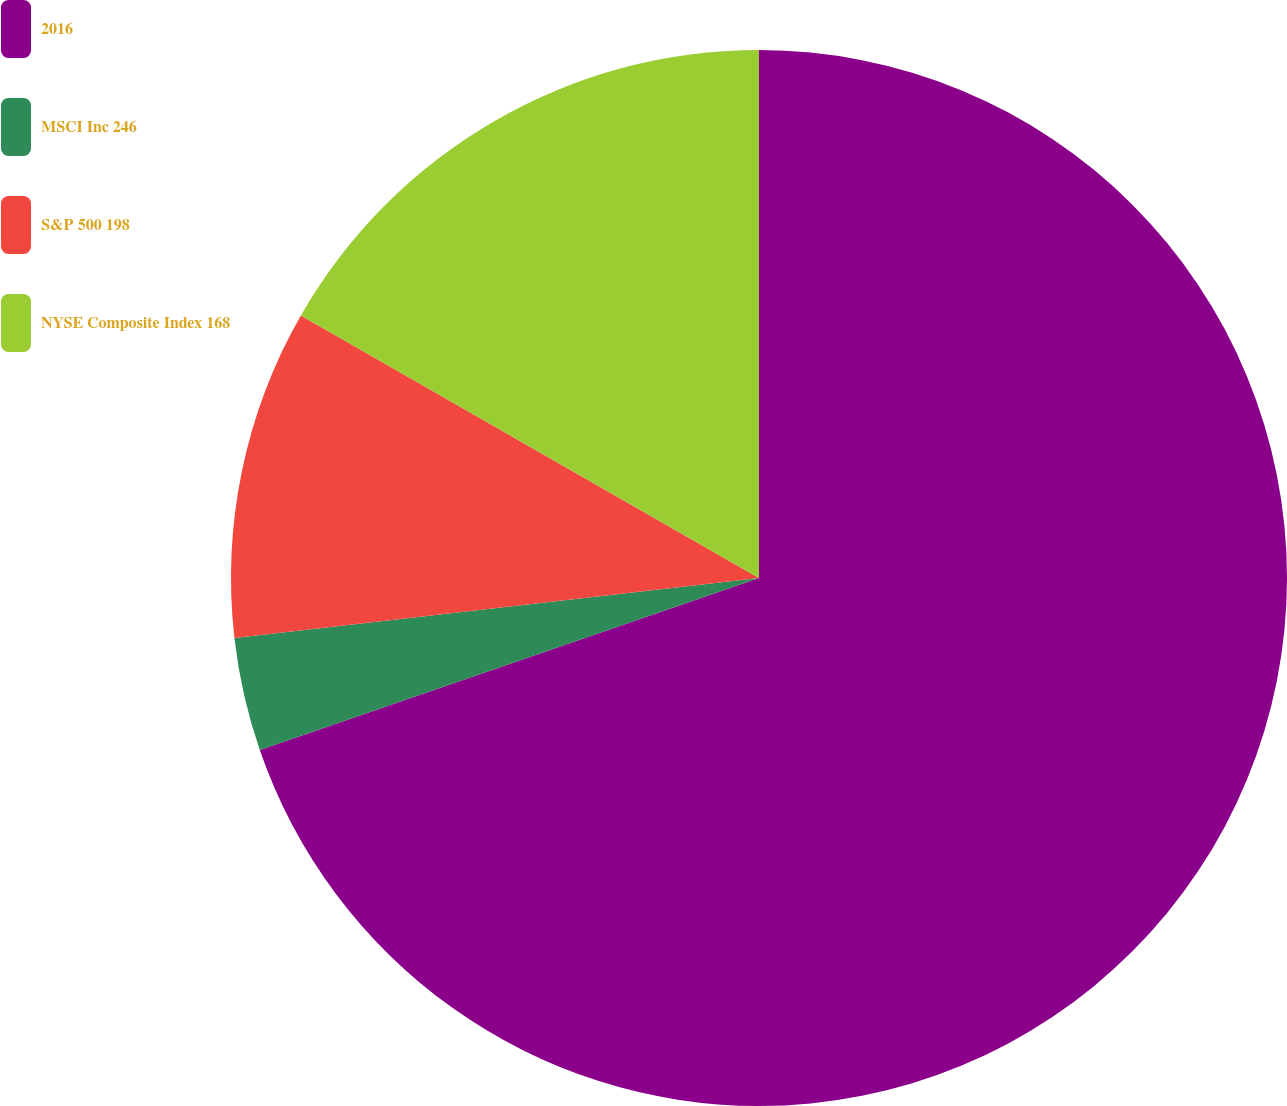Convert chart to OTSL. <chart><loc_0><loc_0><loc_500><loc_500><pie_chart><fcel>2016<fcel>MSCI Inc 246<fcel>S&P 500 198<fcel>NYSE Composite Index 168<nl><fcel>69.72%<fcel>3.47%<fcel>10.09%<fcel>16.72%<nl></chart> 